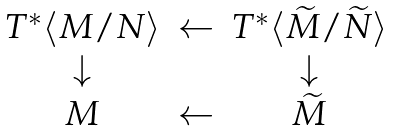Convert formula to latex. <formula><loc_0><loc_0><loc_500><loc_500>\begin{array} { c c c c c } T ^ { * } \langle M / N \rangle & \leftarrow & T ^ { * } \langle \widetilde { M } / \widetilde { N } \rangle \\ \downarrow & & \downarrow \\ M & \leftarrow & \widetilde { M } \end{array}</formula> 